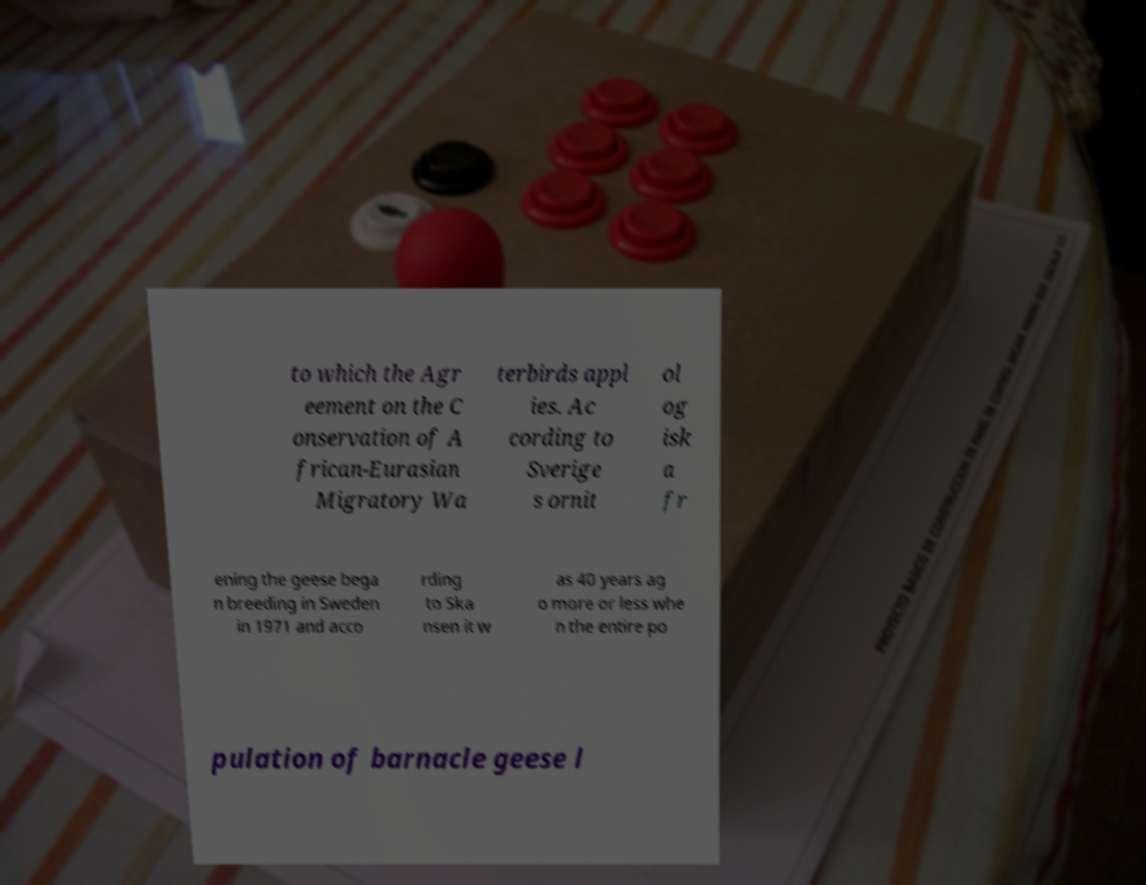Please identify and transcribe the text found in this image. to which the Agr eement on the C onservation of A frican-Eurasian Migratory Wa terbirds appl ies. Ac cording to Sverige s ornit ol og isk a fr ening the geese bega n breeding in Sweden in 1971 and acco rding to Ska nsen it w as 40 years ag o more or less whe n the entire po pulation of barnacle geese l 